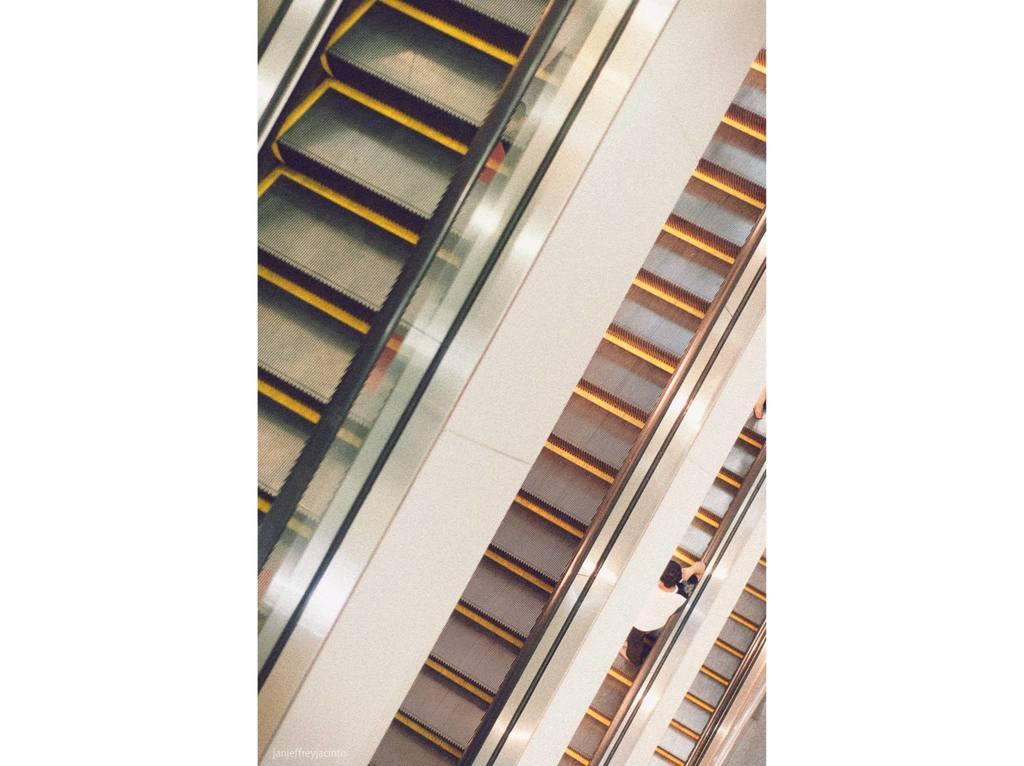What type of transportation is depicted in the image? There are escalators in the image. What feature do the escalators have? The escalators have glass walls. Can you describe the person in the image? There is a person standing on one of the escalators. What musical instrument is the person playing on the escalator? There is no musical instrument present in the image; the person is simply standing on the escalator. 